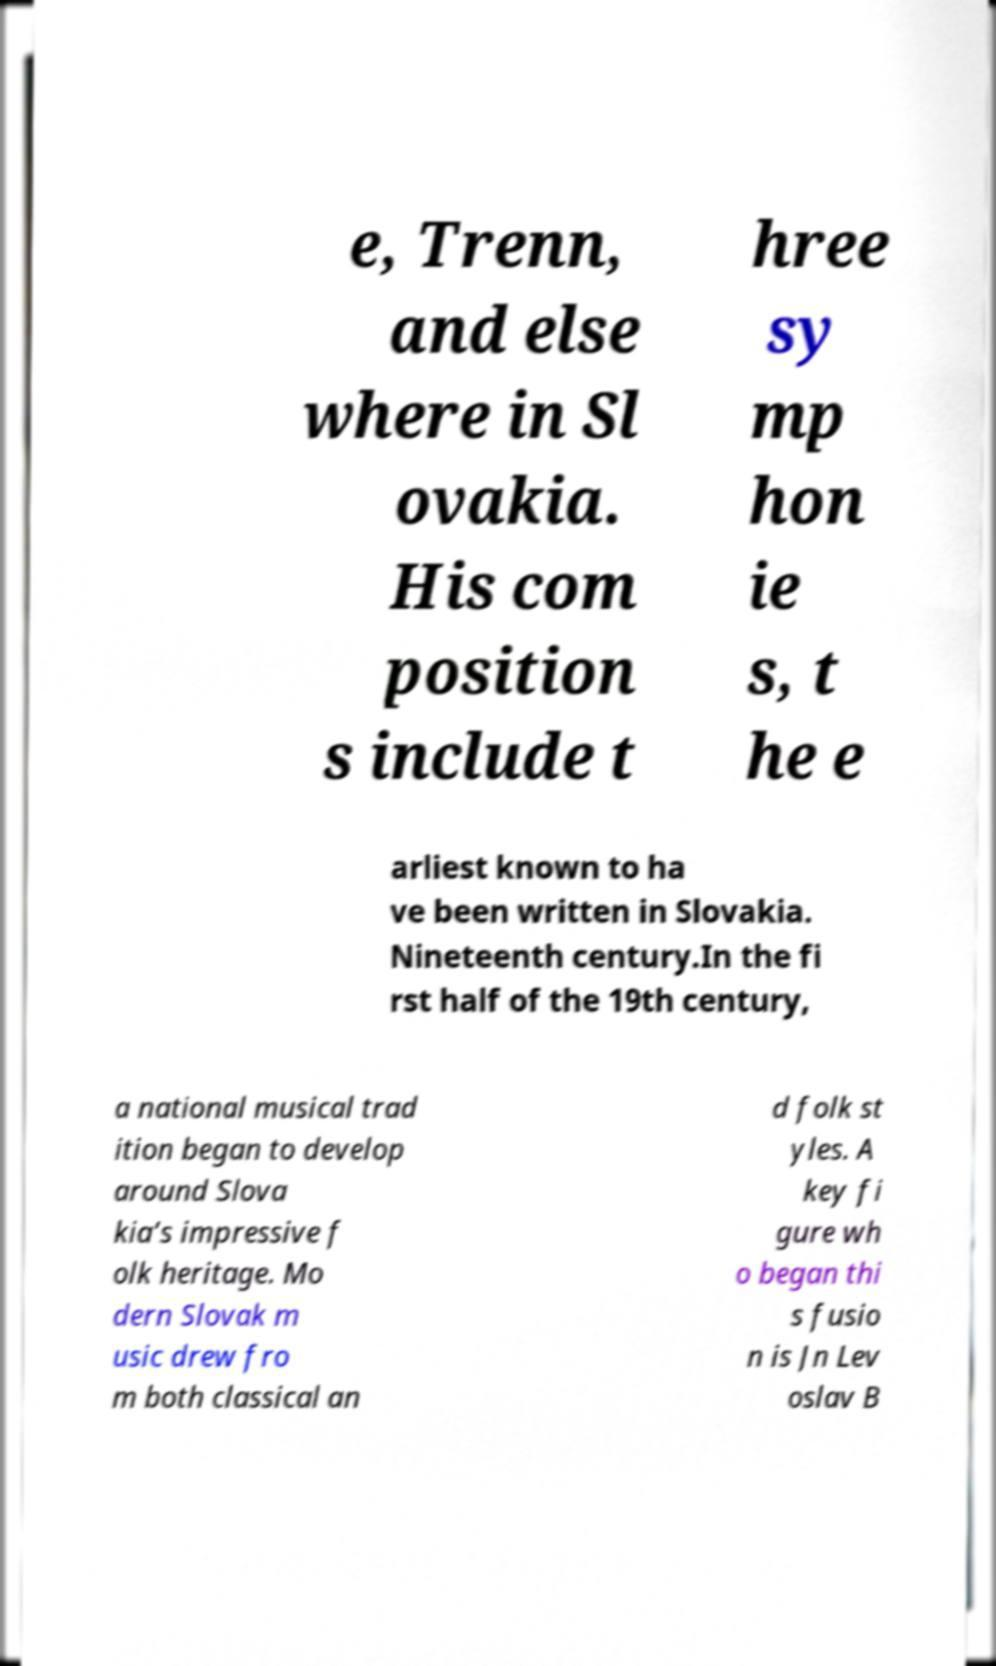Could you assist in decoding the text presented in this image and type it out clearly? e, Trenn, and else where in Sl ovakia. His com position s include t hree sy mp hon ie s, t he e arliest known to ha ve been written in Slovakia. Nineteenth century.In the fi rst half of the 19th century, a national musical trad ition began to develop around Slova kia’s impressive f olk heritage. Mo dern Slovak m usic drew fro m both classical an d folk st yles. A key fi gure wh o began thi s fusio n is Jn Lev oslav B 